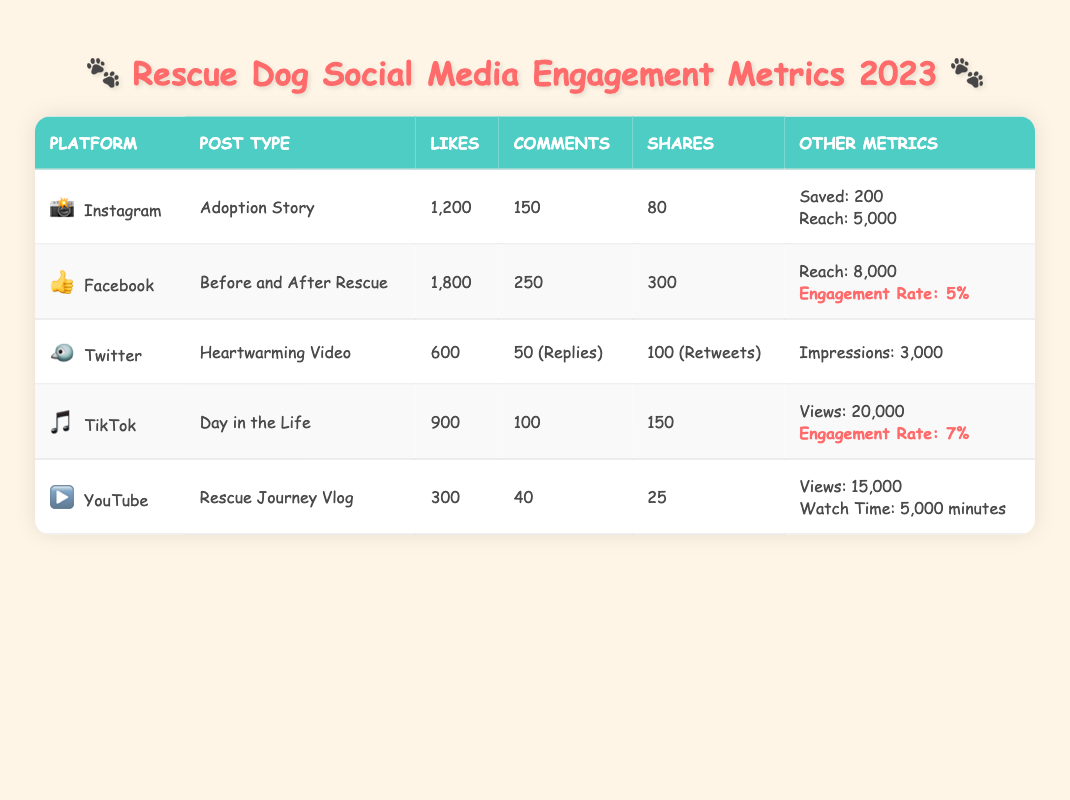What is the highest number of likes on a post? From the table, the highest number of likes is 1800, which is associated with the Facebook post type "Before and After Rescue."
Answer: 1800 Which platform had the most shares? The platform with the most shares is Facebook with 300 shares for the "Before and After Rescue" post.
Answer: Facebook, 300 shares Is the engagement rate for TikTok higher than for Facebook? TikTok has an engagement rate of 7%, while Facebook's engagement rate is 5%. Since 7% is greater than 5%, the statement is true.
Answer: Yes How many total likes are there across all platforms? To find the total likes, we sum the likes over all posts: 1200 (Instagram) + 1800 (Facebook) + 600 (Twitter) + 900 (TikTok) + 300 (YouTube) = 3900.
Answer: 3900 On which platform did the "Rescue Journey Vlog" receive the least engagement in terms of likes and comments combined? For "Rescue Journey Vlog" on YouTube, the combined total of likes (300) and comments (40) is 340. Comparing with other platforms, it has the lowest combined total.
Answer: YouTube What is the average number of comments across all platforms? To find the average comments, add the comments: 150 (Instagram) + 250 (Facebook) + 50 (Twitter) + 100 (TikTok) + 40 (YouTube) = 590. There are 5 posts, so the average is 590 / 5 = 118.
Answer: 118 Did TikTok have more likes than Twitter? TikTok had 900 likes while Twitter only had 600 likes. Therefore, TikTok had more likes than Twitter.
Answer: Yes How many more shares did Facebook have compared to TikTok? Facebook had 300 shares and TikTok had 150 shares. The difference is 300 - 150 = 150 shares more on Facebook than TikTok.
Answer: 150 shares 